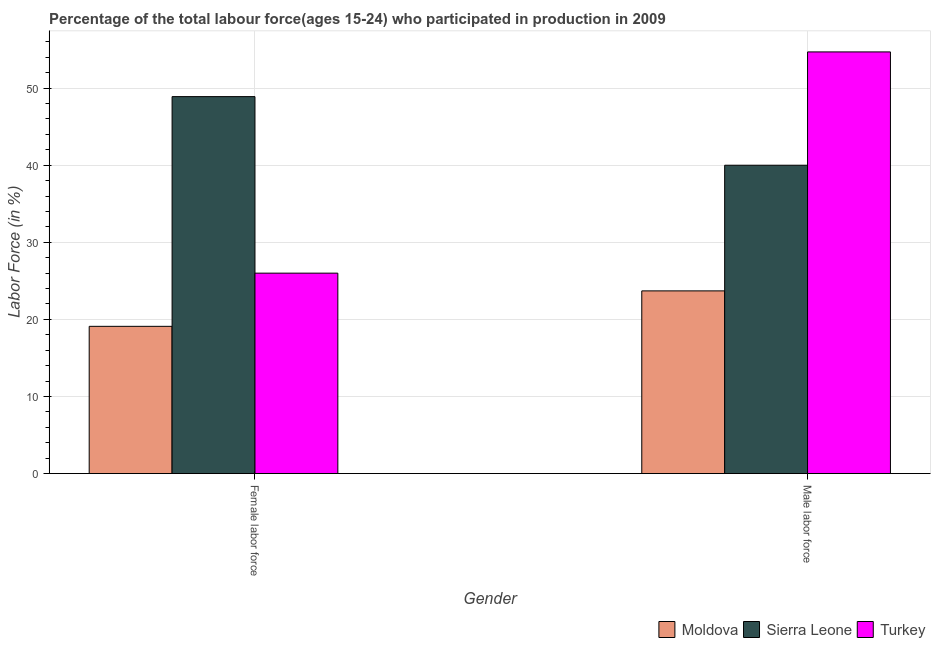How many different coloured bars are there?
Ensure brevity in your answer.  3. How many groups of bars are there?
Keep it short and to the point. 2. Are the number of bars per tick equal to the number of legend labels?
Ensure brevity in your answer.  Yes. Are the number of bars on each tick of the X-axis equal?
Ensure brevity in your answer.  Yes. How many bars are there on the 1st tick from the left?
Your response must be concise. 3. What is the label of the 1st group of bars from the left?
Give a very brief answer. Female labor force. What is the percentage of female labor force in Moldova?
Keep it short and to the point. 19.1. Across all countries, what is the maximum percentage of female labor force?
Offer a very short reply. 48.9. Across all countries, what is the minimum percentage of male labour force?
Your answer should be very brief. 23.7. In which country was the percentage of female labor force maximum?
Make the answer very short. Sierra Leone. In which country was the percentage of male labour force minimum?
Provide a short and direct response. Moldova. What is the total percentage of male labour force in the graph?
Provide a short and direct response. 118.4. What is the difference between the percentage of male labour force in Sierra Leone and that in Moldova?
Offer a terse response. 16.3. What is the difference between the percentage of male labour force in Moldova and the percentage of female labor force in Turkey?
Make the answer very short. -2.3. What is the average percentage of male labour force per country?
Your answer should be compact. 39.47. What is the difference between the percentage of female labor force and percentage of male labour force in Moldova?
Your answer should be compact. -4.6. In how many countries, is the percentage of female labor force greater than 44 %?
Give a very brief answer. 1. What is the ratio of the percentage of female labor force in Moldova to that in Turkey?
Your response must be concise. 0.73. What does the 1st bar from the left in Male labor force represents?
Offer a very short reply. Moldova. Are all the bars in the graph horizontal?
Your answer should be compact. No. Does the graph contain any zero values?
Offer a terse response. No. Does the graph contain grids?
Your response must be concise. Yes. How many legend labels are there?
Ensure brevity in your answer.  3. What is the title of the graph?
Your answer should be compact. Percentage of the total labour force(ages 15-24) who participated in production in 2009. What is the Labor Force (in %) in Moldova in Female labor force?
Your response must be concise. 19.1. What is the Labor Force (in %) in Sierra Leone in Female labor force?
Give a very brief answer. 48.9. What is the Labor Force (in %) of Moldova in Male labor force?
Offer a terse response. 23.7. What is the Labor Force (in %) of Turkey in Male labor force?
Your response must be concise. 54.7. Across all Gender, what is the maximum Labor Force (in %) of Moldova?
Offer a very short reply. 23.7. Across all Gender, what is the maximum Labor Force (in %) in Sierra Leone?
Offer a terse response. 48.9. Across all Gender, what is the maximum Labor Force (in %) in Turkey?
Provide a short and direct response. 54.7. Across all Gender, what is the minimum Labor Force (in %) in Moldova?
Make the answer very short. 19.1. Across all Gender, what is the minimum Labor Force (in %) in Turkey?
Provide a short and direct response. 26. What is the total Labor Force (in %) of Moldova in the graph?
Your response must be concise. 42.8. What is the total Labor Force (in %) in Sierra Leone in the graph?
Ensure brevity in your answer.  88.9. What is the total Labor Force (in %) of Turkey in the graph?
Your answer should be compact. 80.7. What is the difference between the Labor Force (in %) of Moldova in Female labor force and that in Male labor force?
Your answer should be compact. -4.6. What is the difference between the Labor Force (in %) in Turkey in Female labor force and that in Male labor force?
Provide a succinct answer. -28.7. What is the difference between the Labor Force (in %) of Moldova in Female labor force and the Labor Force (in %) of Sierra Leone in Male labor force?
Your response must be concise. -20.9. What is the difference between the Labor Force (in %) in Moldova in Female labor force and the Labor Force (in %) in Turkey in Male labor force?
Your answer should be compact. -35.6. What is the difference between the Labor Force (in %) in Sierra Leone in Female labor force and the Labor Force (in %) in Turkey in Male labor force?
Give a very brief answer. -5.8. What is the average Labor Force (in %) in Moldova per Gender?
Provide a short and direct response. 21.4. What is the average Labor Force (in %) in Sierra Leone per Gender?
Provide a succinct answer. 44.45. What is the average Labor Force (in %) in Turkey per Gender?
Your response must be concise. 40.35. What is the difference between the Labor Force (in %) of Moldova and Labor Force (in %) of Sierra Leone in Female labor force?
Your answer should be compact. -29.8. What is the difference between the Labor Force (in %) of Sierra Leone and Labor Force (in %) of Turkey in Female labor force?
Give a very brief answer. 22.9. What is the difference between the Labor Force (in %) of Moldova and Labor Force (in %) of Sierra Leone in Male labor force?
Make the answer very short. -16.3. What is the difference between the Labor Force (in %) in Moldova and Labor Force (in %) in Turkey in Male labor force?
Your answer should be very brief. -31. What is the difference between the Labor Force (in %) of Sierra Leone and Labor Force (in %) of Turkey in Male labor force?
Keep it short and to the point. -14.7. What is the ratio of the Labor Force (in %) of Moldova in Female labor force to that in Male labor force?
Make the answer very short. 0.81. What is the ratio of the Labor Force (in %) of Sierra Leone in Female labor force to that in Male labor force?
Keep it short and to the point. 1.22. What is the ratio of the Labor Force (in %) of Turkey in Female labor force to that in Male labor force?
Make the answer very short. 0.48. What is the difference between the highest and the second highest Labor Force (in %) in Turkey?
Offer a terse response. 28.7. What is the difference between the highest and the lowest Labor Force (in %) in Sierra Leone?
Keep it short and to the point. 8.9. What is the difference between the highest and the lowest Labor Force (in %) in Turkey?
Offer a terse response. 28.7. 